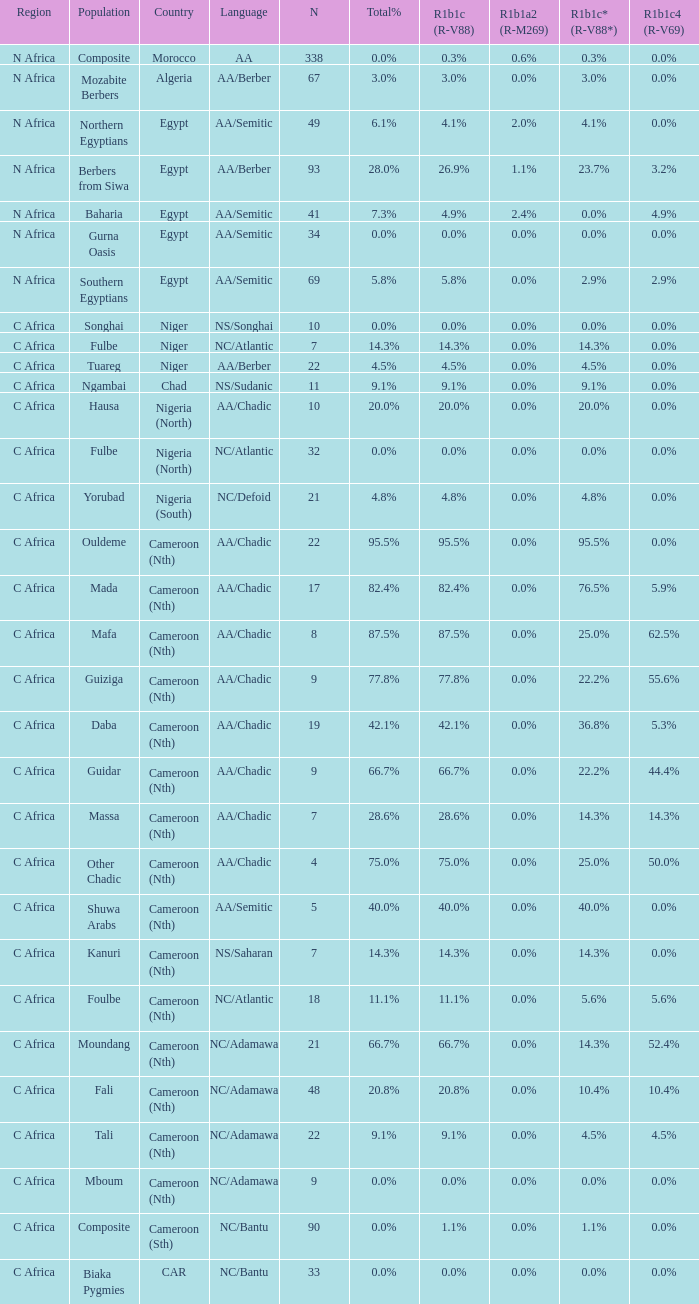What is the largest n value for 55.6% r1b1c4 (r-v69)? 9.0. 